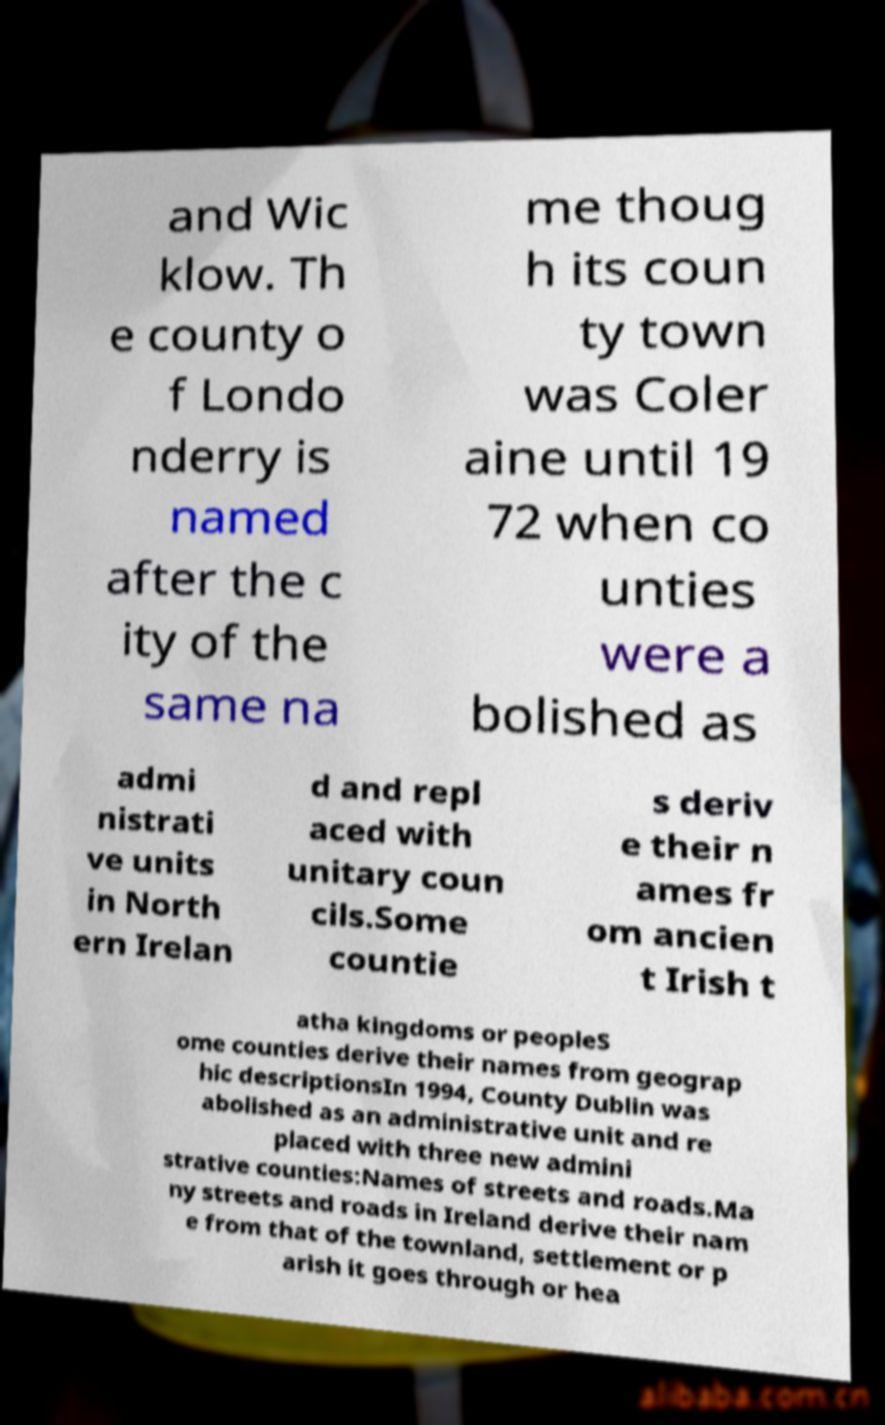Can you accurately transcribe the text from the provided image for me? and Wic klow. Th e county o f Londo nderry is named after the c ity of the same na me thoug h its coun ty town was Coler aine until 19 72 when co unties were a bolished as admi nistrati ve units in North ern Irelan d and repl aced with unitary coun cils.Some countie s deriv e their n ames fr om ancien t Irish t atha kingdoms or peopleS ome counties derive their names from geograp hic descriptionsIn 1994, County Dublin was abolished as an administrative unit and re placed with three new admini strative counties:Names of streets and roads.Ma ny streets and roads in Ireland derive their nam e from that of the townland, settlement or p arish it goes through or hea 